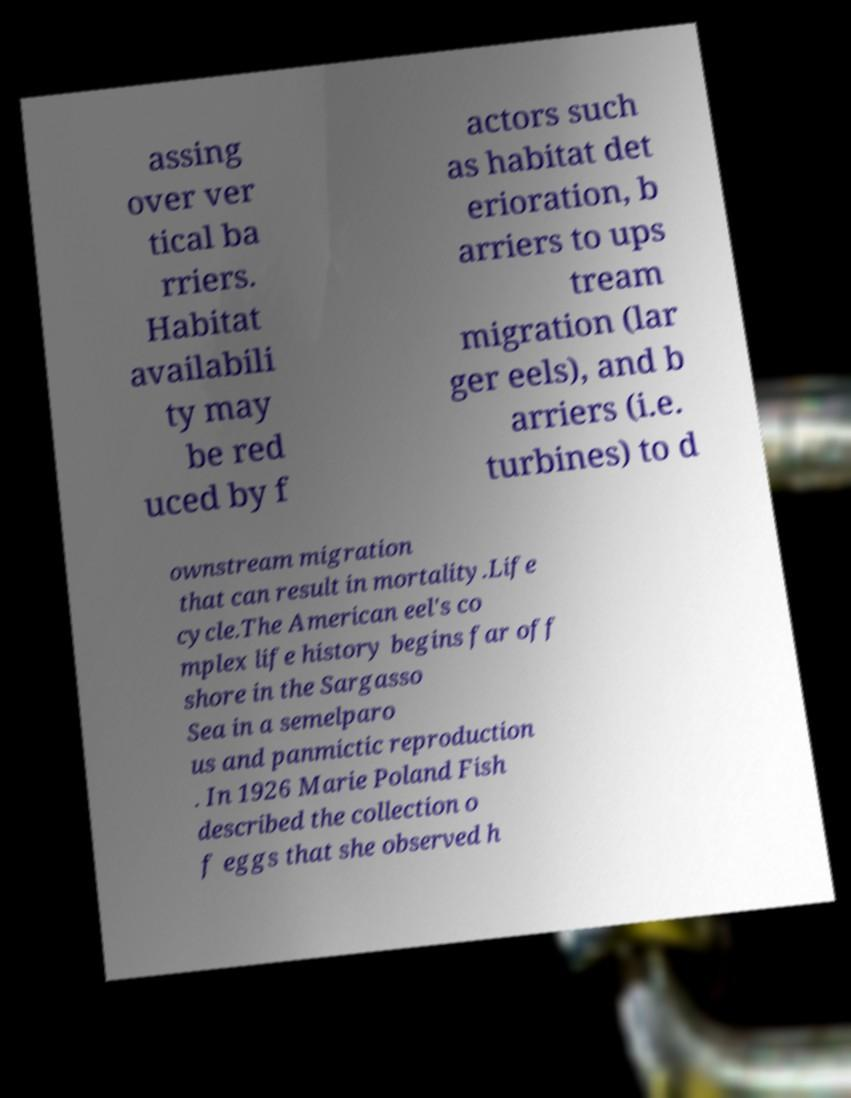Can you accurately transcribe the text from the provided image for me? assing over ver tical ba rriers. Habitat availabili ty may be red uced by f actors such as habitat det erioration, b arriers to ups tream migration (lar ger eels), and b arriers (i.e. turbines) to d ownstream migration that can result in mortality.Life cycle.The American eel's co mplex life history begins far off shore in the Sargasso Sea in a semelparo us and panmictic reproduction . In 1926 Marie Poland Fish described the collection o f eggs that she observed h 